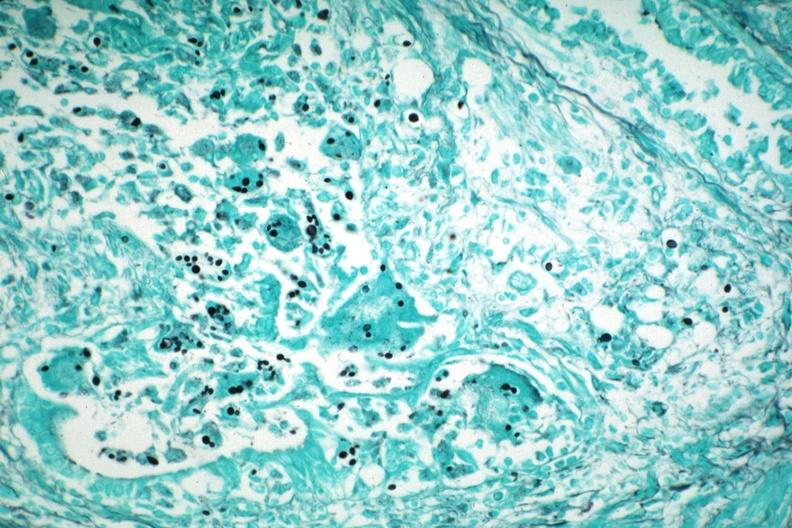what is present?
Answer the question using a single word or phrase. Pneumocystis 